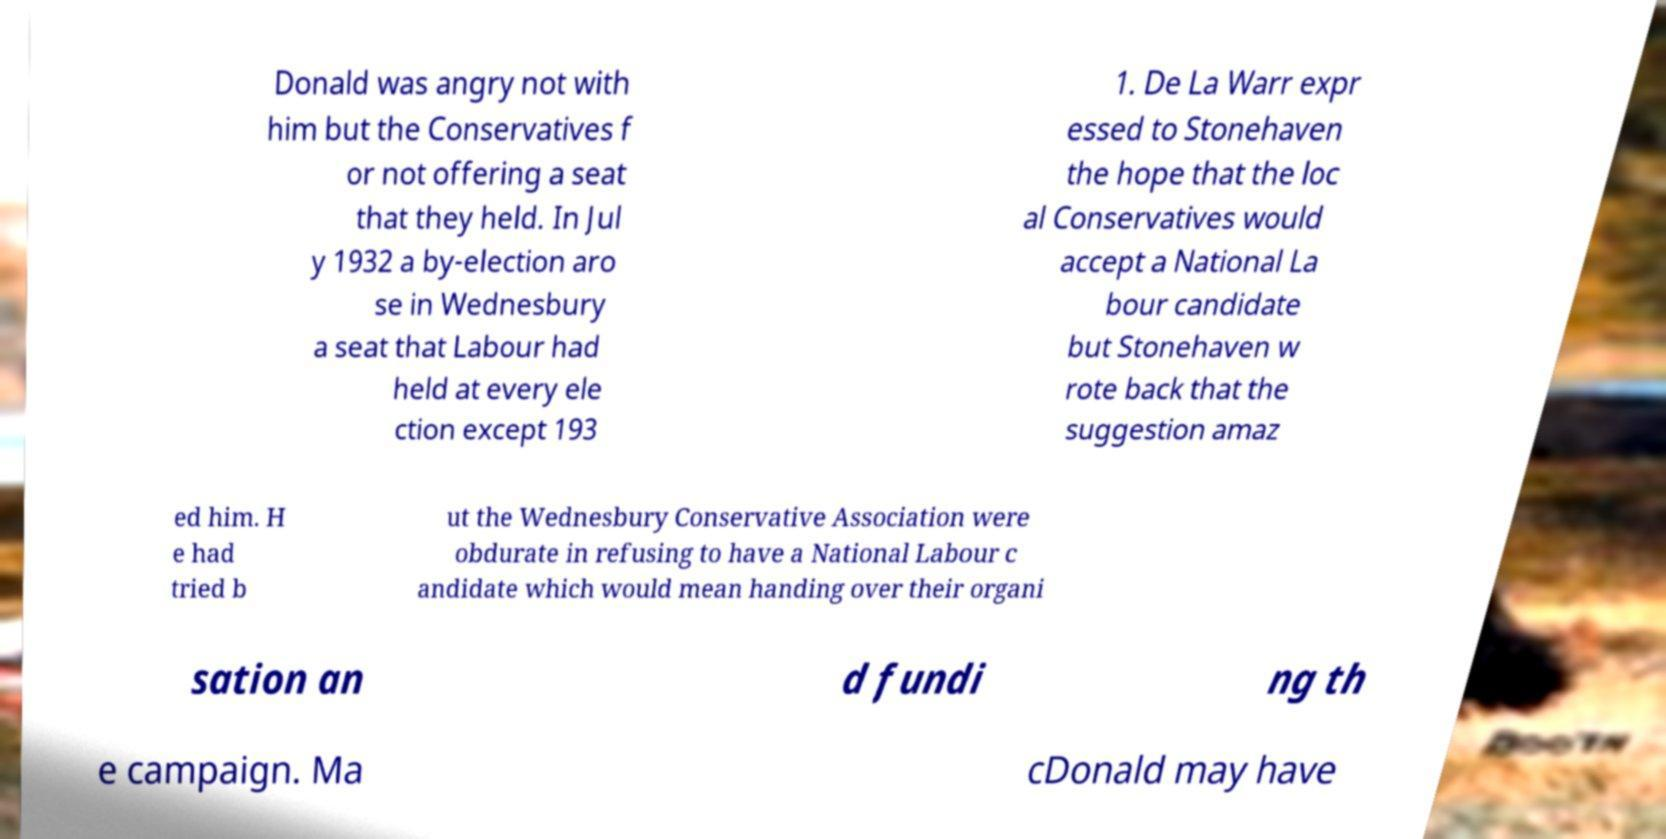What messages or text are displayed in this image? I need them in a readable, typed format. Donald was angry not with him but the Conservatives f or not offering a seat that they held. In Jul y 1932 a by-election aro se in Wednesbury a seat that Labour had held at every ele ction except 193 1. De La Warr expr essed to Stonehaven the hope that the loc al Conservatives would accept a National La bour candidate but Stonehaven w rote back that the suggestion amaz ed him. H e had tried b ut the Wednesbury Conservative Association were obdurate in refusing to have a National Labour c andidate which would mean handing over their organi sation an d fundi ng th e campaign. Ma cDonald may have 